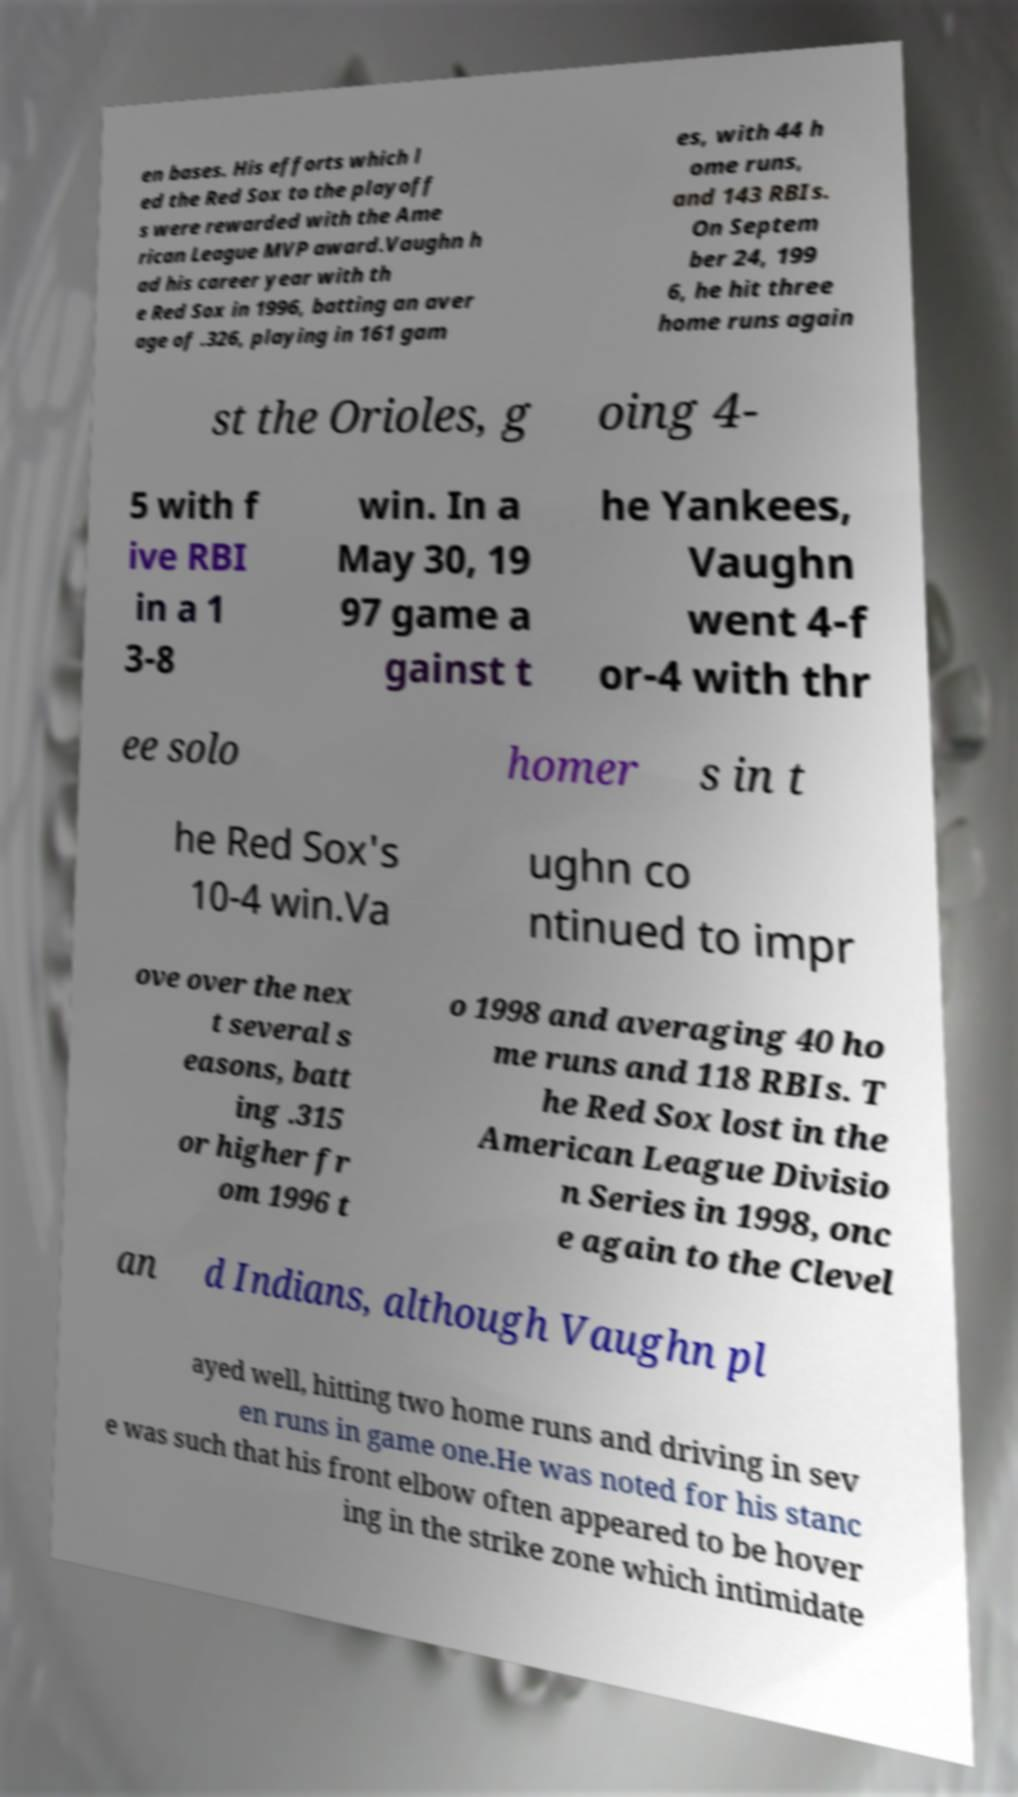Please identify and transcribe the text found in this image. en bases. His efforts which l ed the Red Sox to the playoff s were rewarded with the Ame rican League MVP award.Vaughn h ad his career year with th e Red Sox in 1996, batting an aver age of .326, playing in 161 gam es, with 44 h ome runs, and 143 RBIs. On Septem ber 24, 199 6, he hit three home runs again st the Orioles, g oing 4- 5 with f ive RBI in a 1 3-8 win. In a May 30, 19 97 game a gainst t he Yankees, Vaughn went 4-f or-4 with thr ee solo homer s in t he Red Sox's 10-4 win.Va ughn co ntinued to impr ove over the nex t several s easons, batt ing .315 or higher fr om 1996 t o 1998 and averaging 40 ho me runs and 118 RBIs. T he Red Sox lost in the American League Divisio n Series in 1998, onc e again to the Clevel an d Indians, although Vaughn pl ayed well, hitting two home runs and driving in sev en runs in game one.He was noted for his stanc e was such that his front elbow often appeared to be hover ing in the strike zone which intimidate 